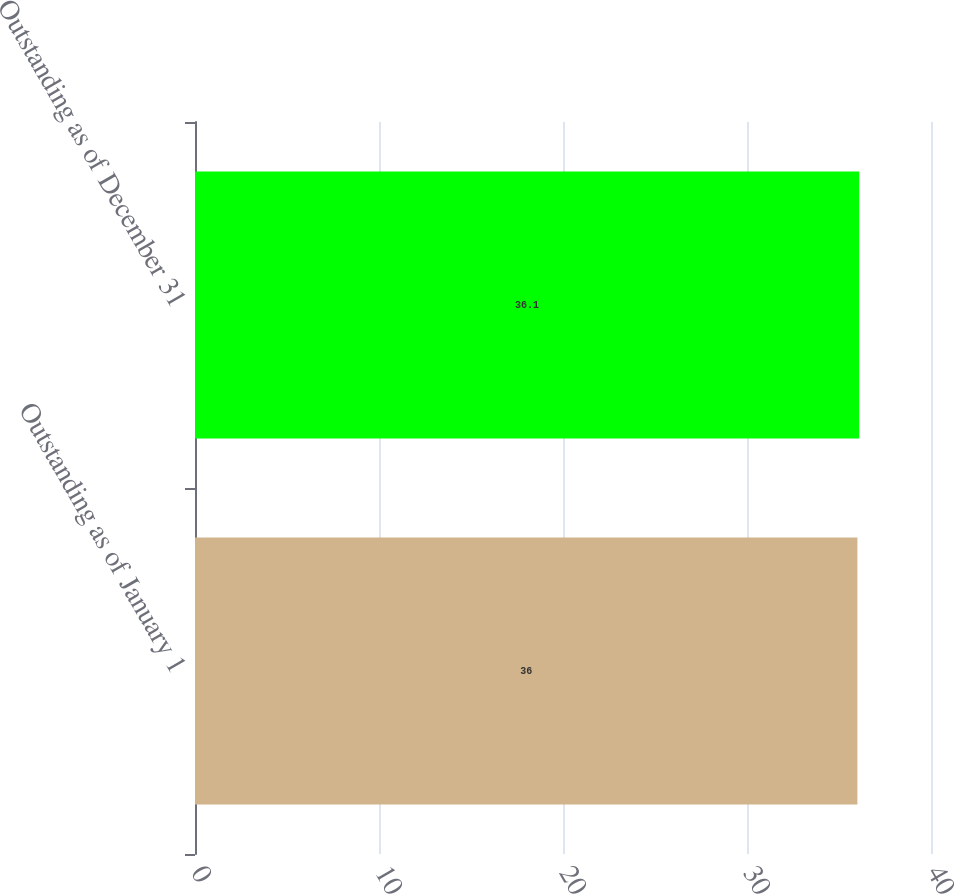Convert chart to OTSL. <chart><loc_0><loc_0><loc_500><loc_500><bar_chart><fcel>Outstanding as of January 1<fcel>Outstanding as of December 31<nl><fcel>36<fcel>36.1<nl></chart> 